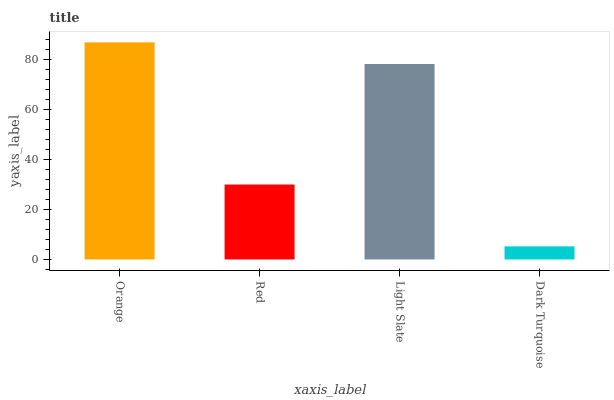Is Red the minimum?
Answer yes or no. No. Is Red the maximum?
Answer yes or no. No. Is Orange greater than Red?
Answer yes or no. Yes. Is Red less than Orange?
Answer yes or no. Yes. Is Red greater than Orange?
Answer yes or no. No. Is Orange less than Red?
Answer yes or no. No. Is Light Slate the high median?
Answer yes or no. Yes. Is Red the low median?
Answer yes or no. Yes. Is Dark Turquoise the high median?
Answer yes or no. No. Is Light Slate the low median?
Answer yes or no. No. 